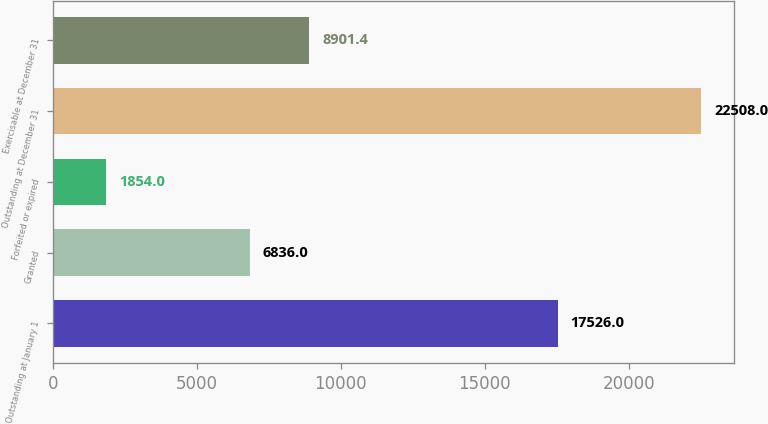<chart> <loc_0><loc_0><loc_500><loc_500><bar_chart><fcel>Outstanding at January 1<fcel>Granted<fcel>Forfeited or expired<fcel>Outstanding at December 31<fcel>Exercisable at December 31<nl><fcel>17526<fcel>6836<fcel>1854<fcel>22508<fcel>8901.4<nl></chart> 